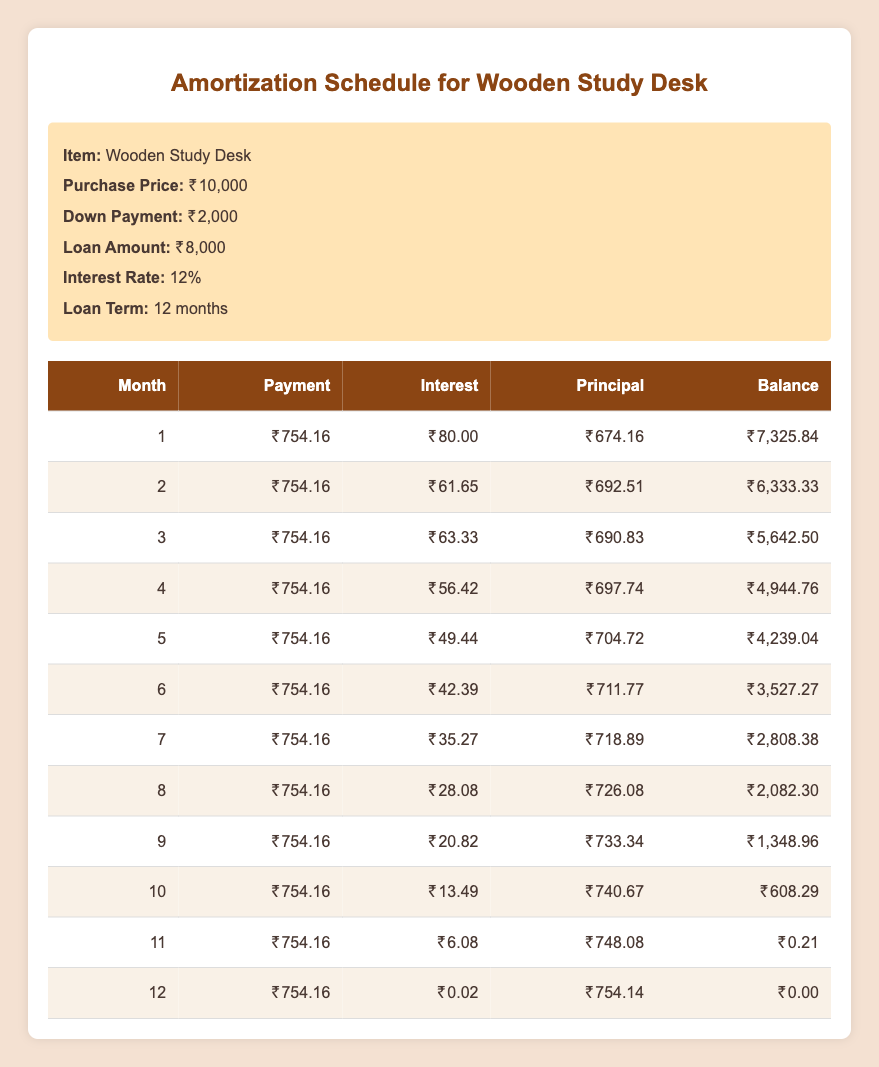What is the monthly payment for the wooden study desk? The monthly payment amount is shown as ₹754.16 for each month in the table under the "Payment" column.
Answer: ₹754.16 How much interest do I pay in the first month? In the first month, the interest payment listed in the table is ₹80.00, directly found in the "Interest" column of the first row.
Answer: ₹80.00 What is the total principal paid by the end of the loan term? To calculate the total principal paid, add all values in the "Principal" column. The total is (674.16 + 692.51 + 690.83 + 697.74 + 704.72 + 711.77 + 718.89 + 726.08 + 733.34 + 740.67 + 748.08 + 754.14) = ₹8,000.00.
Answer: ₹8,000.00 Is the interest payment lower in the second month compared to the first month? The interest payment in the second month is ₹61.65, which is lower than the first month's interest payment of ₹80.00. This shows that the interest payment decreases over time as the principal balance lowers.
Answer: Yes What is the remaining balance after the 6th month? The remaining balance after the 6th month is listed as ₹3,527.27 in the "Balance" column of the sixth row, which shows how much is still owed on the loan.
Answer: ₹3,527.27 Calculate the average monthly payment over the loan term? The average monthly payment is calculated by taking the total payment paid over 12 months. Each month is ₹754.16, so the average is ₹754.16 (since it is constant).
Answer: ₹754.16 Which month has the highest principal payment? The month with the highest principal payment is the 11th month, where the principal payment is ₹748.08, found in the "Principal" column of the 11th row.
Answer: 11th month How much is the interest payment in the last month? The interest payment in the last month (12th month) is ₹0.02, as stated in the "Interest" column of the last row.
Answer: ₹0.02 By how much does the principal payment increase from the 1st to the 5th month? To find this difference, look at the "Principal" for the 1st month (674.16) and the 5th month (704.72). The increase is 704.72 - 674.16 = ₹30.56.
Answer: ₹30.56 